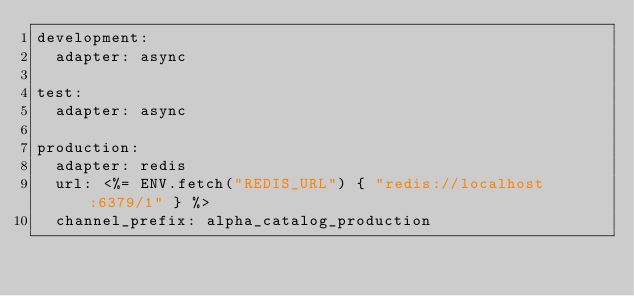<code> <loc_0><loc_0><loc_500><loc_500><_YAML_>development:
  adapter: async

test:
  adapter: async

production:
  adapter: redis
  url: <%= ENV.fetch("REDIS_URL") { "redis://localhost:6379/1" } %>
  channel_prefix: alpha_catalog_production
</code> 